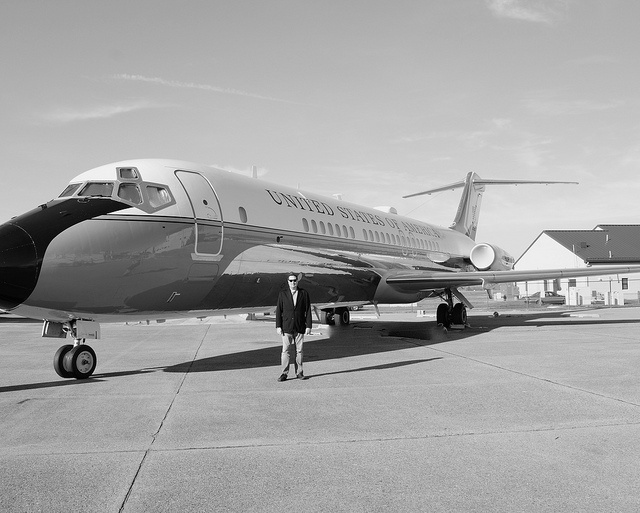Describe the objects in this image and their specific colors. I can see airplane in darkgray, gray, black, and lightgray tones, people in darkgray, black, gray, and lightgray tones, and car in darkgray, gray, black, and lightgray tones in this image. 